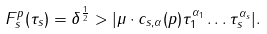<formula> <loc_0><loc_0><loc_500><loc_500>F _ { s } ^ { p } ( \tau _ { s } ) = \delta ^ { \frac { 1 } { 2 } } > | \mu \cdot c _ { s , \alpha } ( p ) \tau _ { 1 } ^ { \alpha _ { 1 } } \dots \tau _ { s } ^ { \alpha _ { s } } | .</formula> 